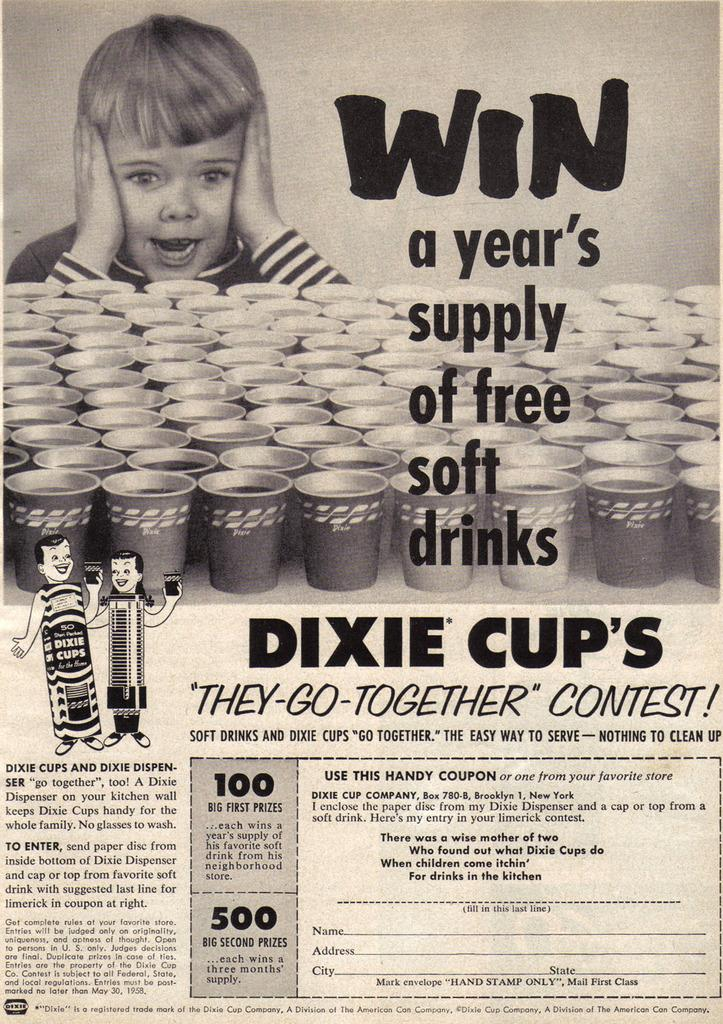What is the main subject of the image? There is a photo in the image. What can be seen in the photo? There is a kid in the photo, as well as glasses. Is there any text present in the photo? Yes, there is text on the photo. How many cakes are visible in the photo? There are no cakes present in the photo; it features a kid, glasses, and text. Are there any dolls interacting with the kid in the photo? There are no dolls present in the photo; it only features a kid, glasses, and text. 